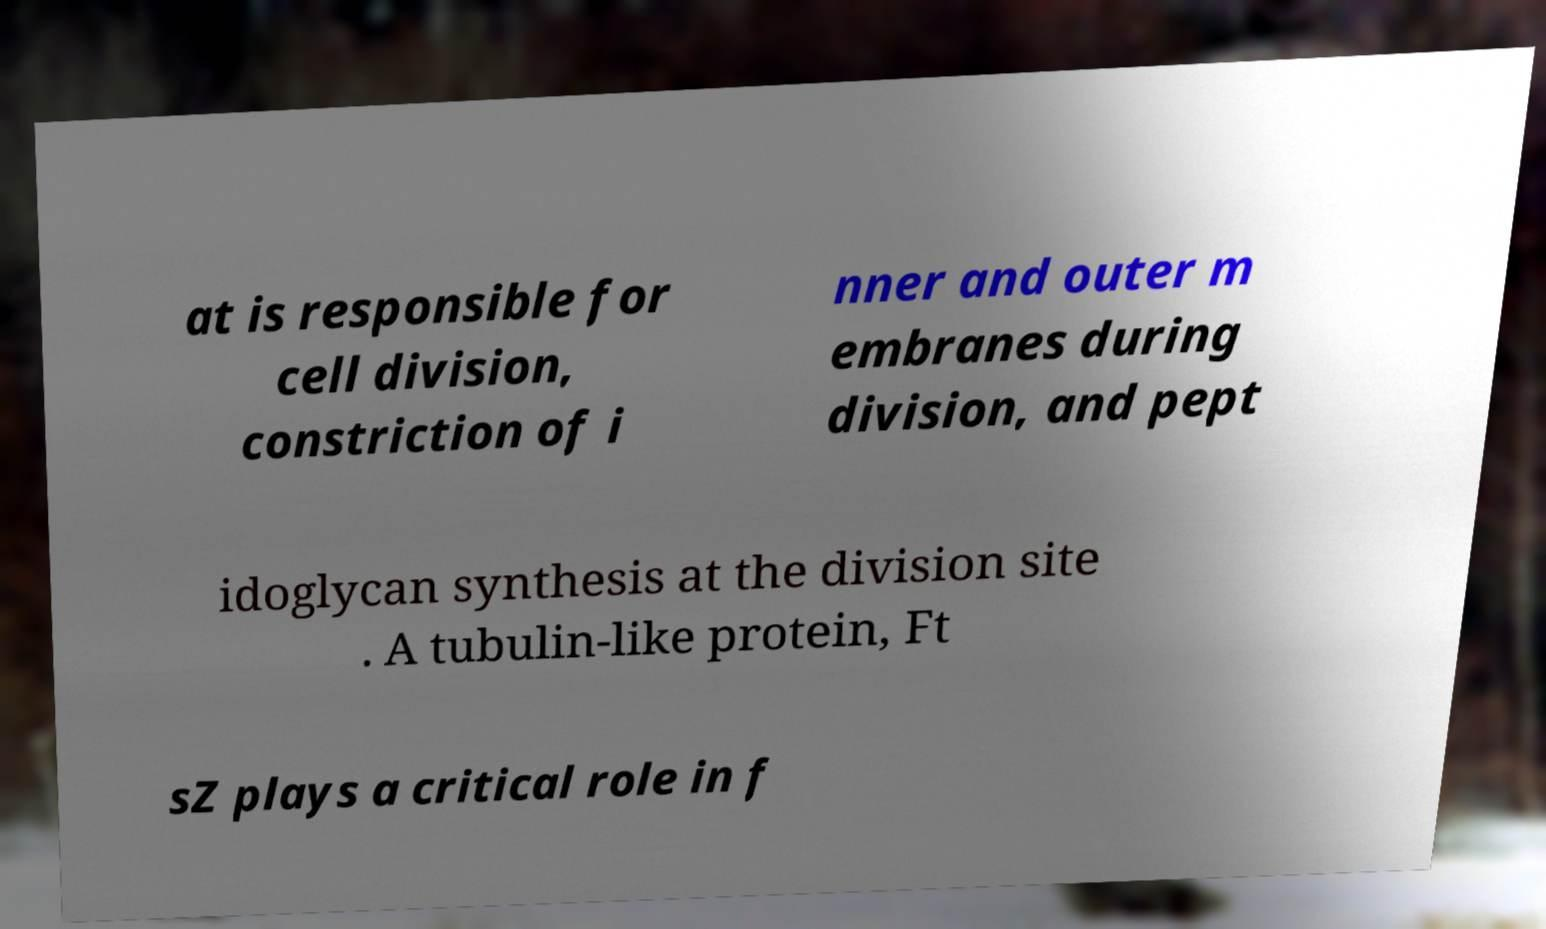Can you read and provide the text displayed in the image?This photo seems to have some interesting text. Can you extract and type it out for me? at is responsible for cell division, constriction of i nner and outer m embranes during division, and pept idoglycan synthesis at the division site . A tubulin-like protein, Ft sZ plays a critical role in f 